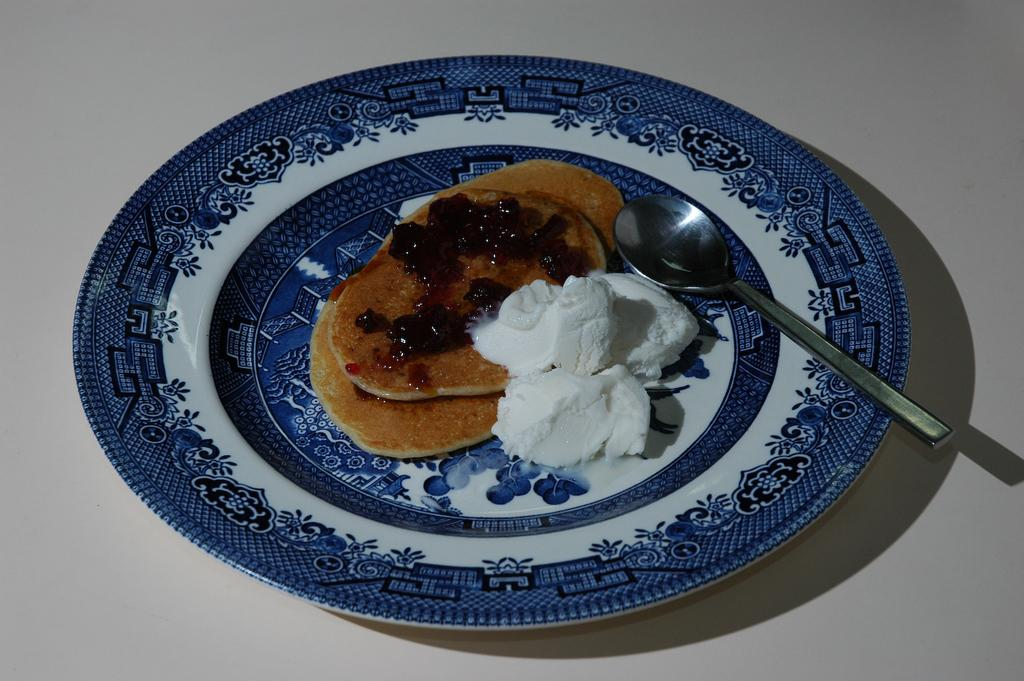What is on the plate that is visible in the image? There is a plate with food in the image. What utensil is present in the image? There is a spoon in the image. What color is the background of the image? The background of the image is white. What arithmetic problem is being solved on the plate in the image? There is no arithmetic problem present on the plate in the image; it contains food. What type of wall can be seen in the image? There is no wall visible in the image; the background is white. 